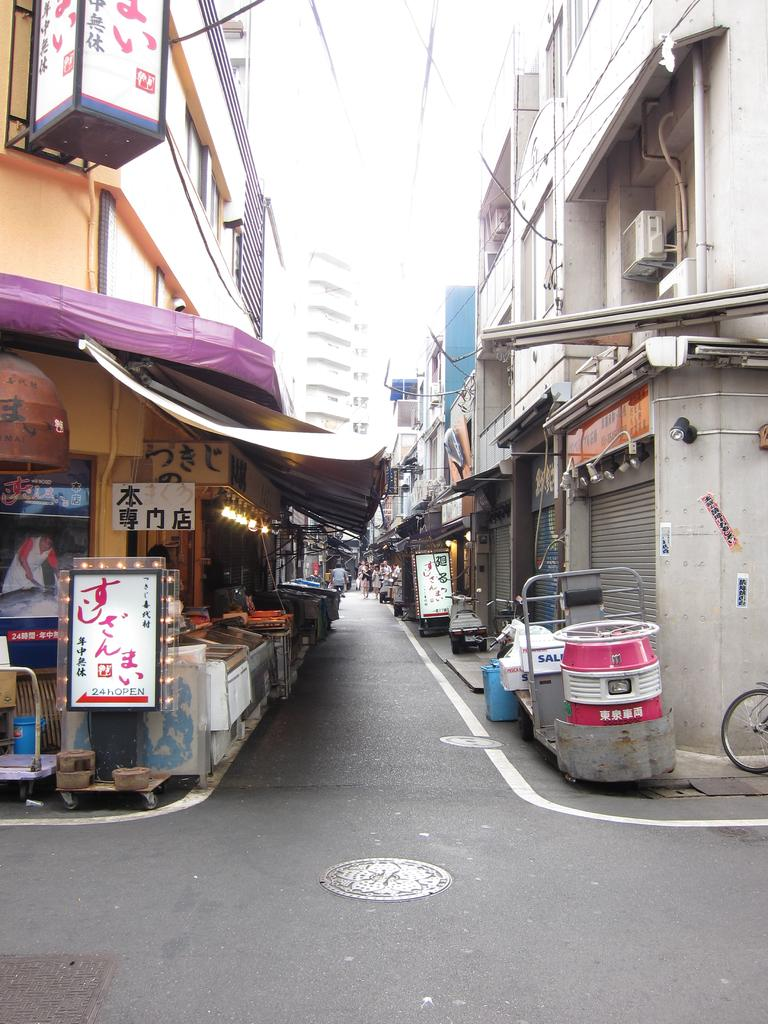What can be seen on the road in the image? There are manholes on the road in the image. What is visible in the background of the image? There are buildings, people, shutters, boards, lights, and some objects in the background of the image. How does the fog affect the visibility of the mailbox in the image? There is no mailbox present in the image, so the fog's effect on its visibility cannot be determined. 